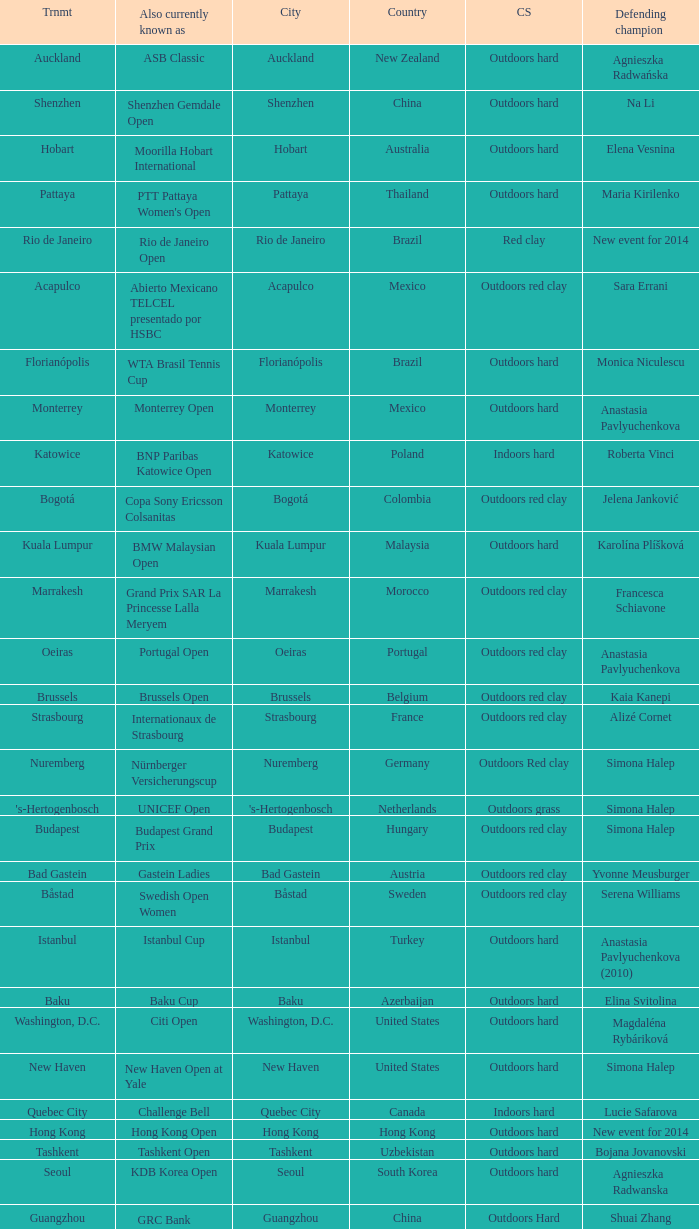What tournament is in katowice? Katowice. 